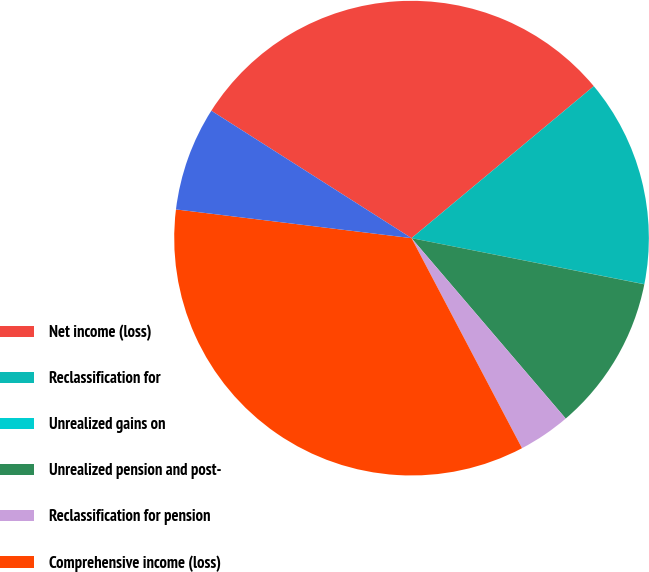Convert chart. <chart><loc_0><loc_0><loc_500><loc_500><pie_chart><fcel>Net income (loss)<fcel>Reclassification for<fcel>Unrealized gains on<fcel>Unrealized pension and post-<fcel>Reclassification for pension<fcel>Comprehensive income (loss)<fcel>Comprehensive income<nl><fcel>29.92%<fcel>14.17%<fcel>0.01%<fcel>10.63%<fcel>3.55%<fcel>34.64%<fcel>7.09%<nl></chart> 